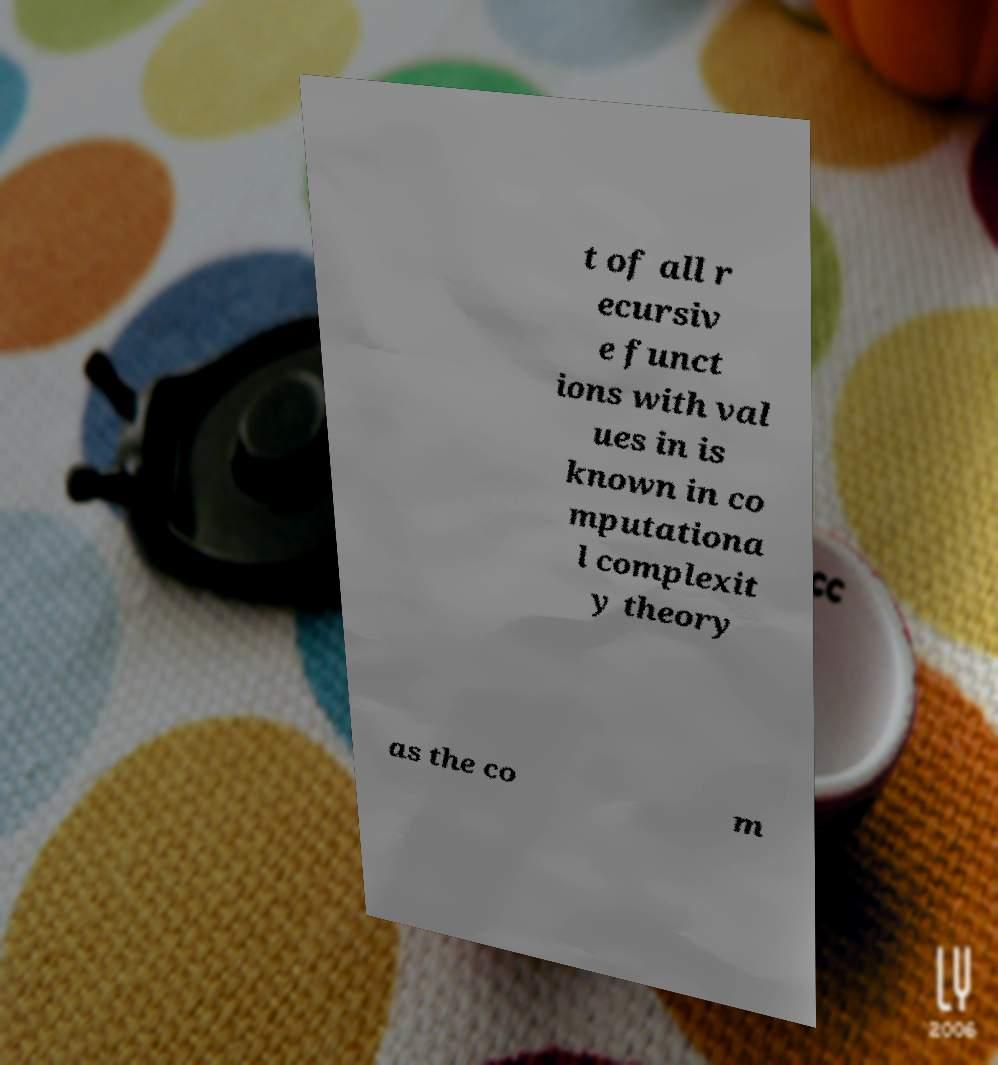Could you extract and type out the text from this image? t of all r ecursiv e funct ions with val ues in is known in co mputationa l complexit y theory as the co m 